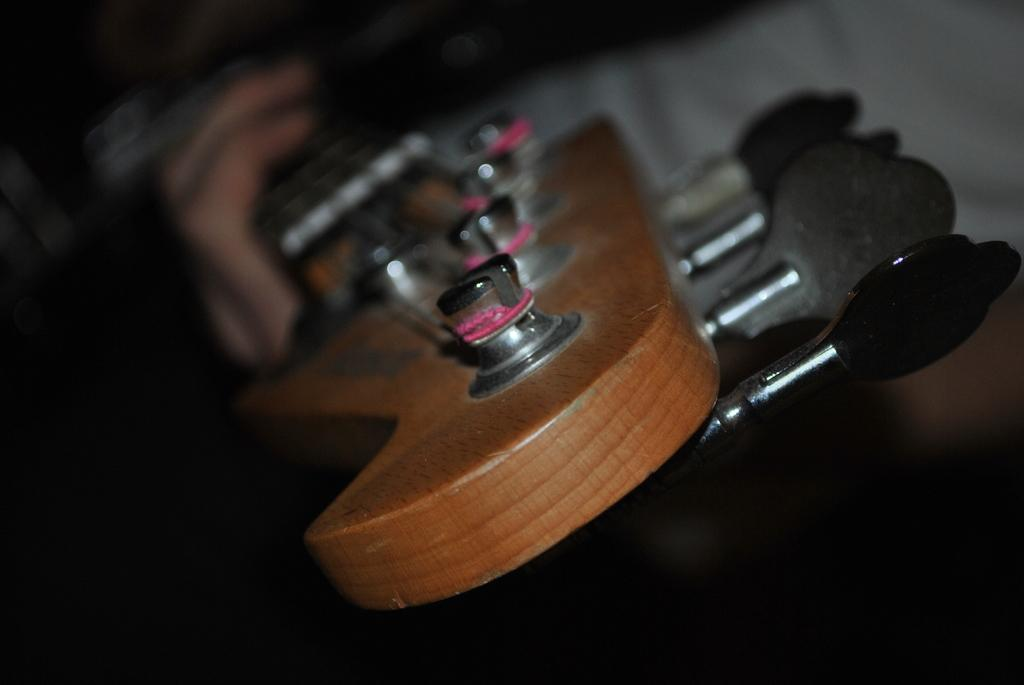What musical instrument is visible in the image? There is a guitar in the image. Can you describe the perspective of the image? The image provides a close-up look at the guitar. What type of lipstick is the guitar wearing in the image? The guitar is not wearing lipstick, as it is an inanimate object and does not have the ability to wear makeup. 